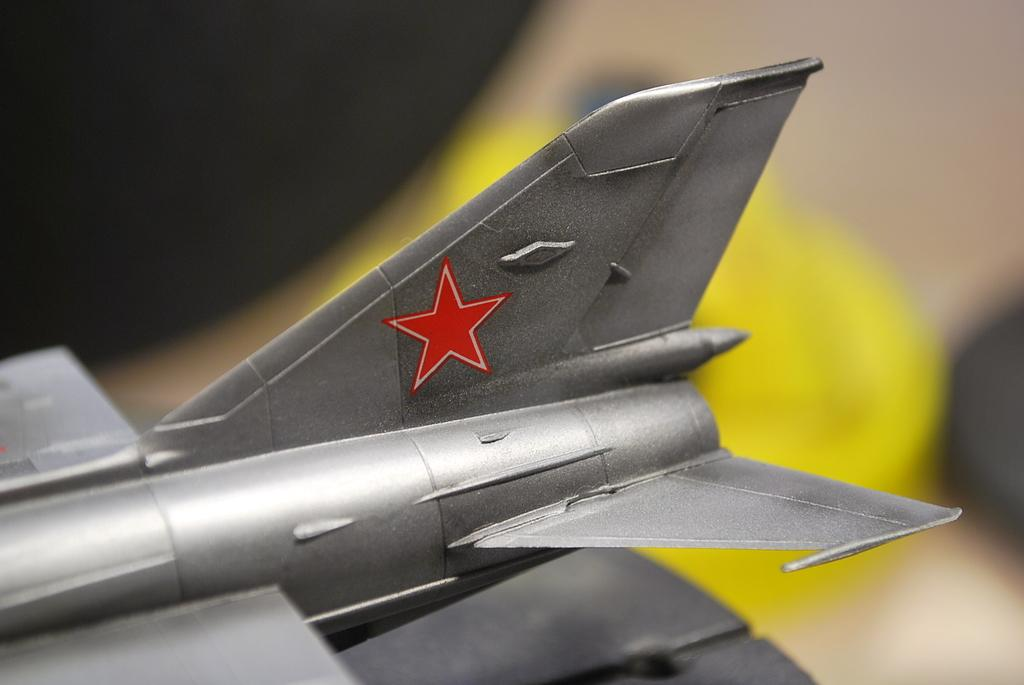What is the main subject of the image? There is a Dassault Rafale in the center of the image. Can you describe the background of the image? The background area is blurred. What type of sound can be heard coming from the playground in the image? There is no playground present in the image, so it's not possible to determine what, if any, sounds might be heard. 